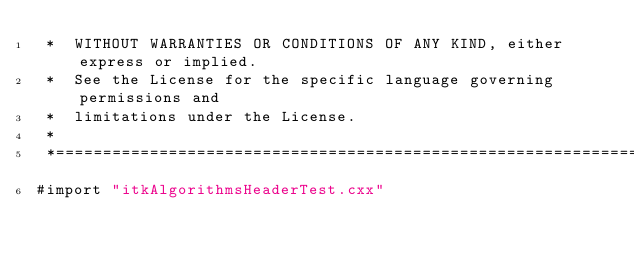Convert code to text. <code><loc_0><loc_0><loc_500><loc_500><_ObjectiveC_> *  WITHOUT WARRANTIES OR CONDITIONS OF ANY KIND, either express or implied.
 *  See the License for the specific language governing permissions and
 *  limitations under the License.
 *
 *=========================================================================*/
#import "itkAlgorithmsHeaderTest.cxx"
</code> 